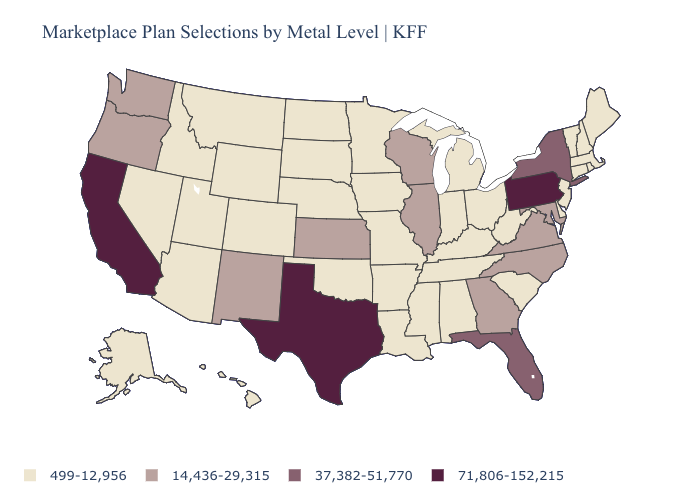What is the value of Alabama?
Give a very brief answer. 499-12,956. Does the first symbol in the legend represent the smallest category?
Short answer required. Yes. What is the highest value in the Northeast ?
Short answer required. 71,806-152,215. What is the value of Kansas?
Give a very brief answer. 14,436-29,315. Name the states that have a value in the range 37,382-51,770?
Short answer required. Florida, New York. Among the states that border Missouri , which have the highest value?
Give a very brief answer. Illinois, Kansas. Does Oklahoma have the same value as Rhode Island?
Quick response, please. Yes. Name the states that have a value in the range 37,382-51,770?
Keep it brief. Florida, New York. What is the lowest value in the USA?
Keep it brief. 499-12,956. Which states hav the highest value in the Northeast?
Short answer required. Pennsylvania. What is the value of New York?
Give a very brief answer. 37,382-51,770. What is the lowest value in the USA?
Concise answer only. 499-12,956. 